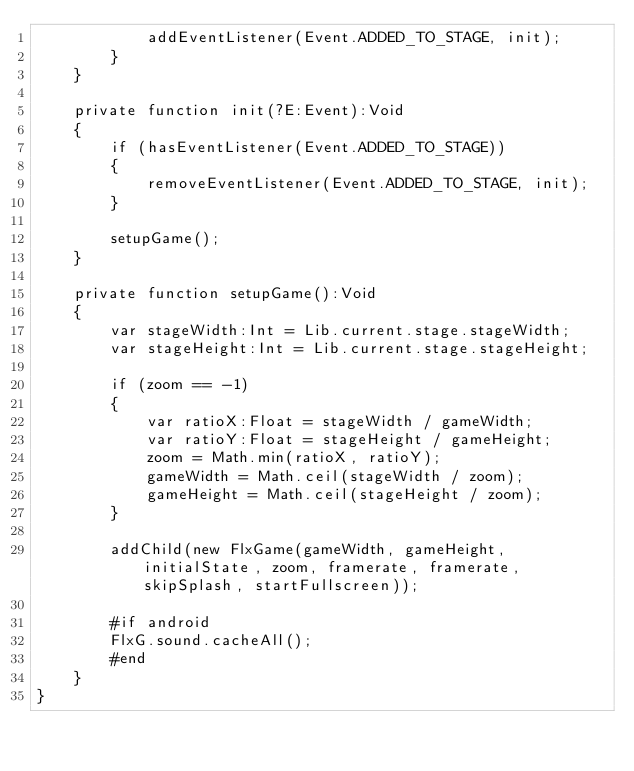<code> <loc_0><loc_0><loc_500><loc_500><_Haxe_>			addEventListener(Event.ADDED_TO_STAGE, init);
		}
	}
	
	private function init(?E:Event):Void 
	{
		if (hasEventListener(Event.ADDED_TO_STAGE))
		{
			removeEventListener(Event.ADDED_TO_STAGE, init);
		}
		
		setupGame();
	}
	
	private function setupGame():Void
	{
		var stageWidth:Int = Lib.current.stage.stageWidth;
		var stageHeight:Int = Lib.current.stage.stageHeight;

		if (zoom == -1)
		{
			var ratioX:Float = stageWidth / gameWidth;
			var ratioY:Float = stageHeight / gameHeight;
			zoom = Math.min(ratioX, ratioY);
			gameWidth = Math.ceil(stageWidth / zoom);
			gameHeight = Math.ceil(stageHeight / zoom);
		}

		addChild(new FlxGame(gameWidth, gameHeight, initialState, zoom, framerate, framerate, skipSplash, startFullscreen));
		
		#if android
		FlxG.sound.cacheAll();
		#end
	}
}</code> 